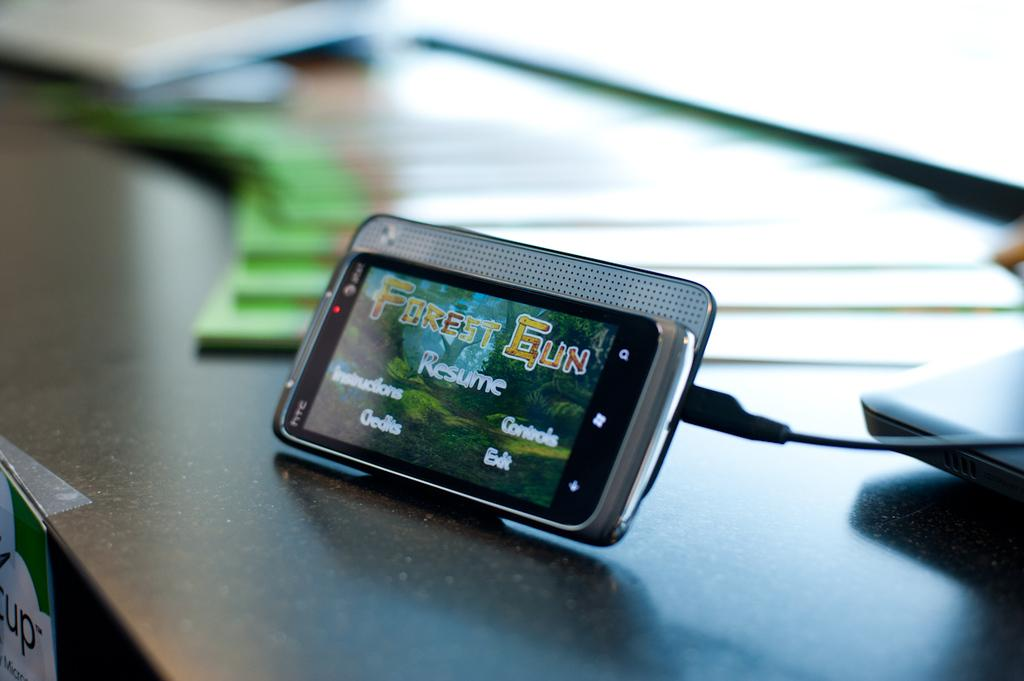<image>
Offer a succinct explanation of the picture presented. A propped up cell phone is displaying a game called Forest Gun 